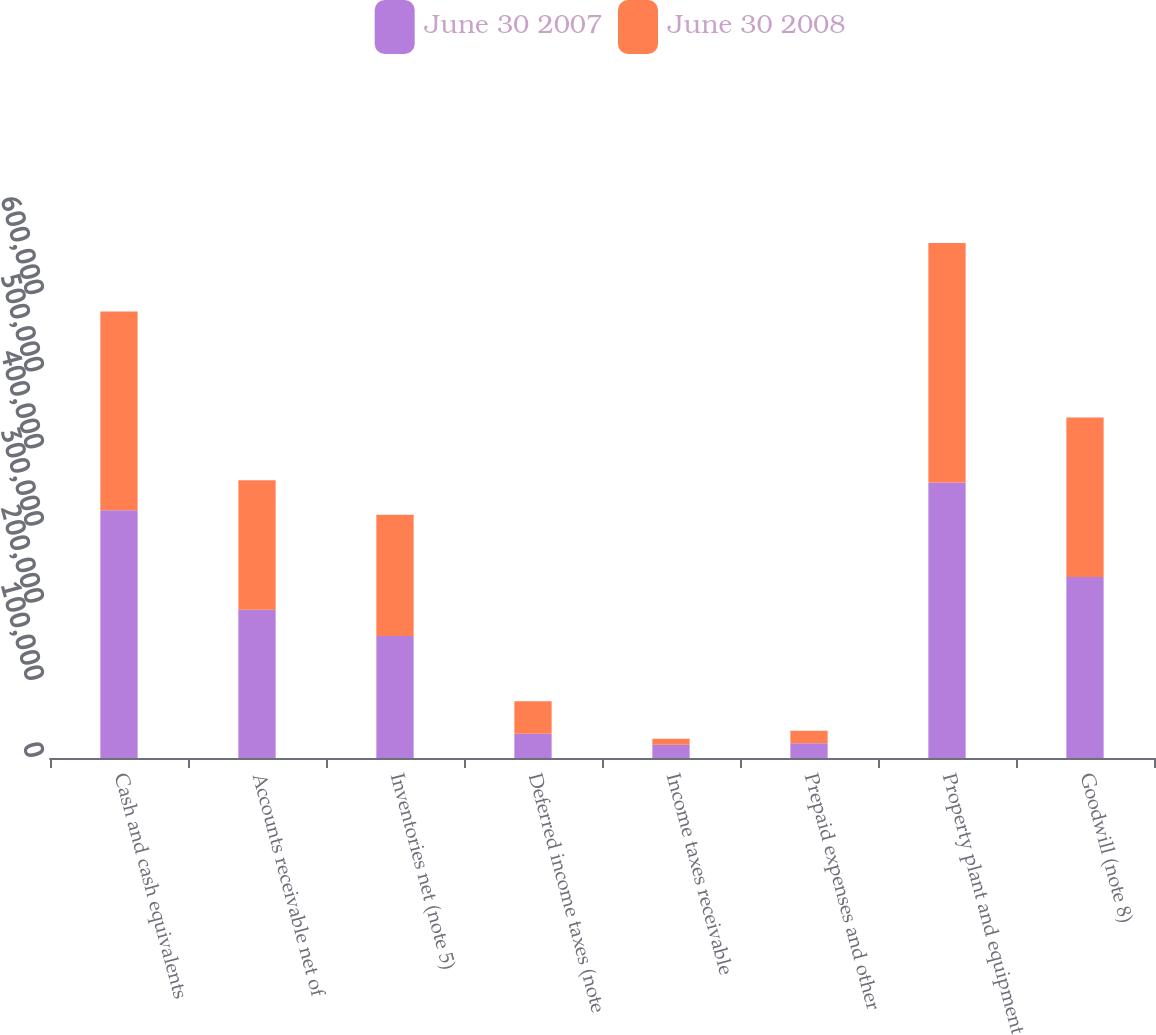Convert chart. <chart><loc_0><loc_0><loc_500><loc_500><stacked_bar_chart><ecel><fcel>Cash and cash equivalents<fcel>Accounts receivable net of<fcel>Inventories net (note 5)<fcel>Deferred income taxes (note<fcel>Income taxes receivable<fcel>Prepaid expenses and other<fcel>Property plant and equipment<fcel>Goodwill (note 8)<nl><fcel>June 30 2007<fcel>321078<fcel>192200<fcel>158251<fcel>31355<fcel>17115<fcel>19241<fcel>357057<fcel>234647<nl><fcel>June 30 2008<fcel>257792<fcel>167821<fcel>157204<fcel>42109<fcel>7952<fcel>15971<fcel>310580<fcel>206778<nl></chart> 